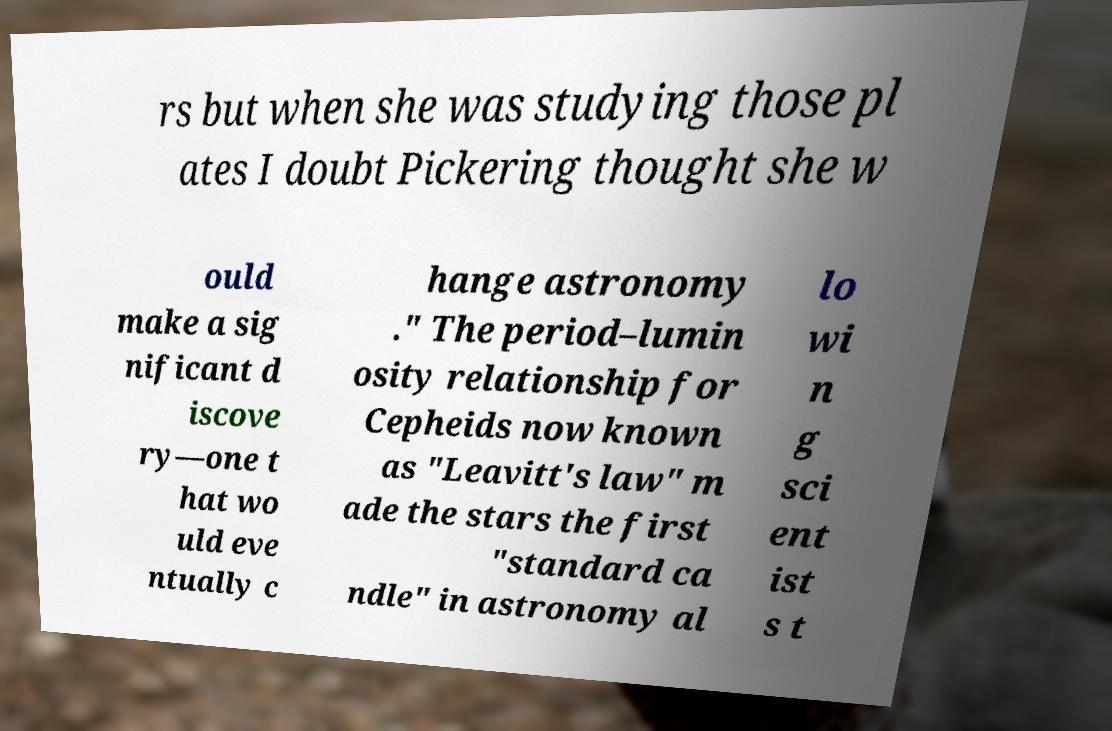Could you assist in decoding the text presented in this image and type it out clearly? rs but when she was studying those pl ates I doubt Pickering thought she w ould make a sig nificant d iscove ry—one t hat wo uld eve ntually c hange astronomy ." The period–lumin osity relationship for Cepheids now known as "Leavitt's law" m ade the stars the first "standard ca ndle" in astronomy al lo wi n g sci ent ist s t 